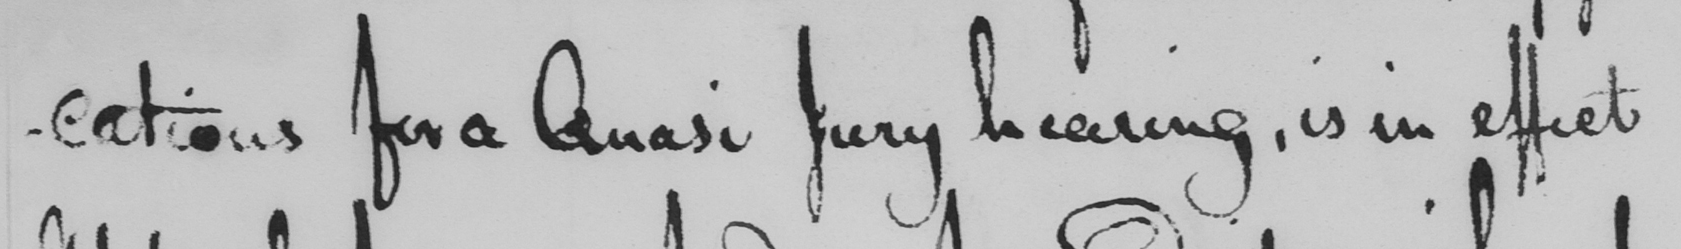Can you read and transcribe this handwriting? -cations for a Quasi Jury hearing , is in effect 